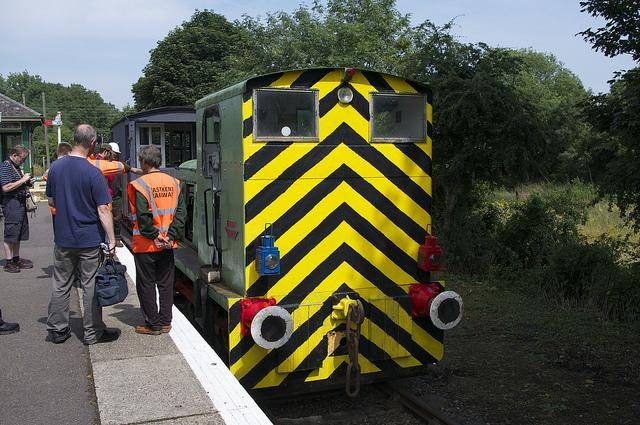Why are the men wearing orange vests? Please explain your reasoning. visibility. The orange pattern is very bright and sticks out against most backgrounds. 